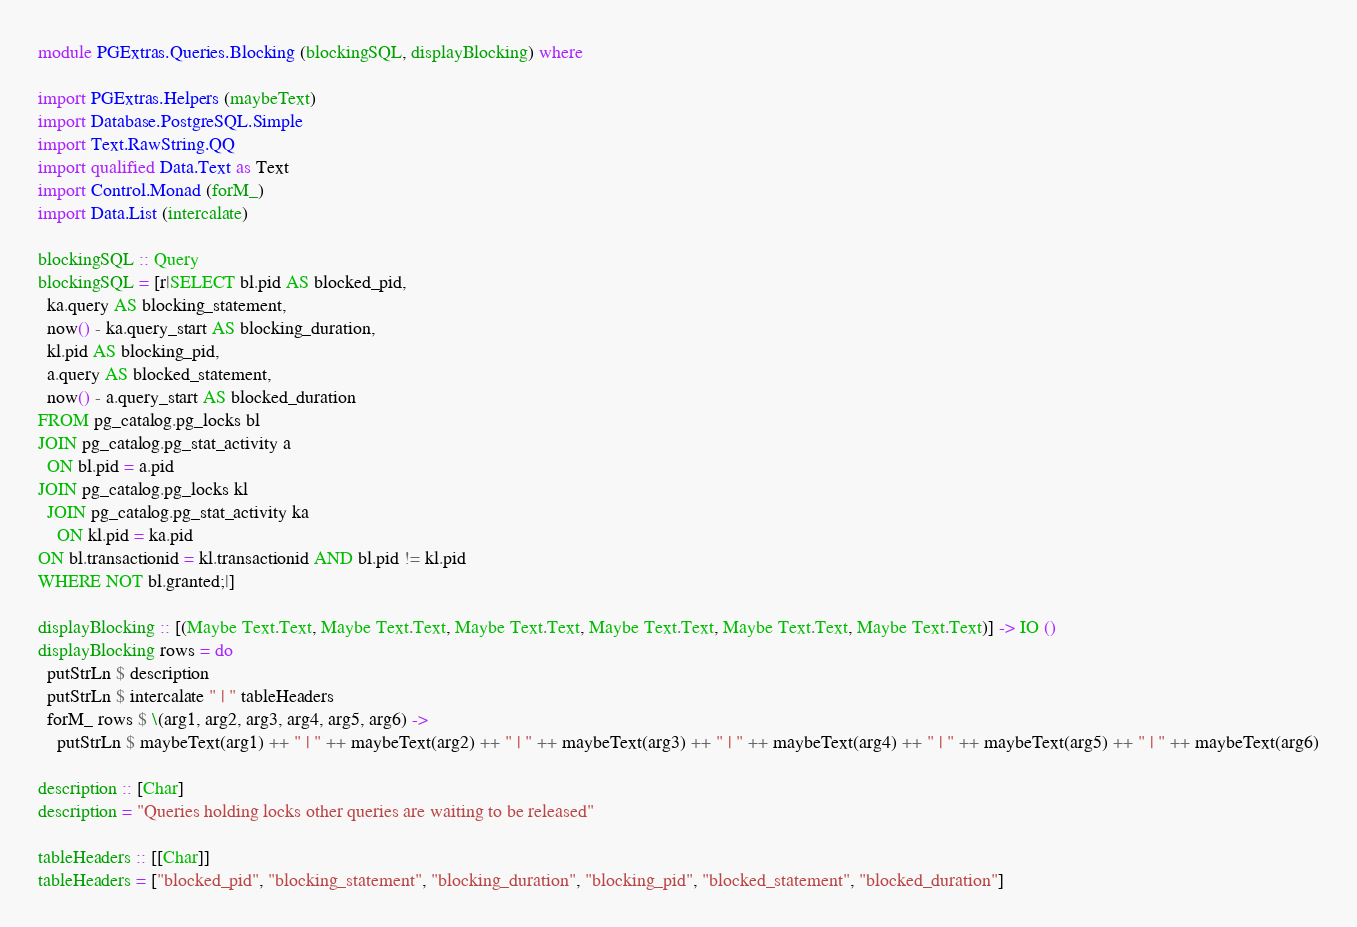<code> <loc_0><loc_0><loc_500><loc_500><_Haskell_>
module PGExtras.Queries.Blocking (blockingSQL, displayBlocking) where

import PGExtras.Helpers (maybeText)
import Database.PostgreSQL.Simple
import Text.RawString.QQ
import qualified Data.Text as Text
import Control.Monad (forM_)
import Data.List (intercalate)

blockingSQL :: Query
blockingSQL = [r|SELECT bl.pid AS blocked_pid,
  ka.query AS blocking_statement,
  now() - ka.query_start AS blocking_duration,
  kl.pid AS blocking_pid,
  a.query AS blocked_statement,
  now() - a.query_start AS blocked_duration
FROM pg_catalog.pg_locks bl
JOIN pg_catalog.pg_stat_activity a
  ON bl.pid = a.pid
JOIN pg_catalog.pg_locks kl
  JOIN pg_catalog.pg_stat_activity ka
    ON kl.pid = ka.pid
ON bl.transactionid = kl.transactionid AND bl.pid != kl.pid
WHERE NOT bl.granted;|]

displayBlocking :: [(Maybe Text.Text, Maybe Text.Text, Maybe Text.Text, Maybe Text.Text, Maybe Text.Text, Maybe Text.Text)] -> IO ()
displayBlocking rows = do
  putStrLn $ description
  putStrLn $ intercalate " | " tableHeaders
  forM_ rows $ \(arg1, arg2, arg3, arg4, arg5, arg6) ->
    putStrLn $ maybeText(arg1) ++ " | " ++ maybeText(arg2) ++ " | " ++ maybeText(arg3) ++ " | " ++ maybeText(arg4) ++ " | " ++ maybeText(arg5) ++ " | " ++ maybeText(arg6)

description :: [Char]
description = "Queries holding locks other queries are waiting to be released"

tableHeaders :: [[Char]]
tableHeaders = ["blocked_pid", "blocking_statement", "blocking_duration", "blocking_pid", "blocked_statement", "blocked_duration"]
</code> 